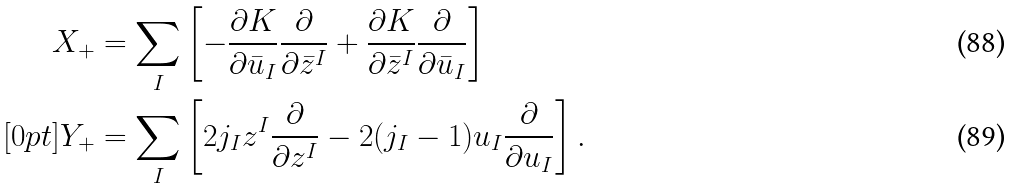Convert formula to latex. <formula><loc_0><loc_0><loc_500><loc_500>X _ { + } & = \sum _ { I } \left [ - \frac { \partial K } { \partial \bar { u } _ { I } } \frac { \partial } { \partial \bar { z } ^ { I } } + \frac { \partial K } { \partial \bar { z } ^ { I } } \frac { \partial } { \partial \bar { u } _ { I } } \right ] \\ [ 0 p t ] Y _ { + } & = \sum _ { I } \left [ 2 j _ { I } z ^ { I } \frac { \partial } { \partial z ^ { I } } - 2 ( j _ { I } - 1 ) u _ { I } \frac { \partial } { \partial u _ { I } } \right ] .</formula> 